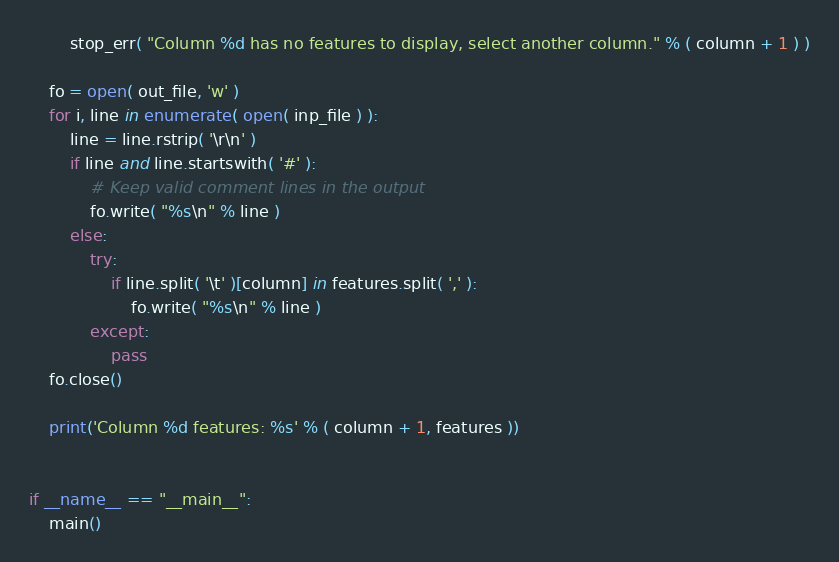<code> <loc_0><loc_0><loc_500><loc_500><_Python_>        stop_err( "Column %d has no features to display, select another column." % ( column + 1 ) )

    fo = open( out_file, 'w' )
    for i, line in enumerate( open( inp_file ) ):
        line = line.rstrip( '\r\n' )
        if line and line.startswith( '#' ):
            # Keep valid comment lines in the output
            fo.write( "%s\n" % line )
        else:
            try:
                if line.split( '\t' )[column] in features.split( ',' ):
                    fo.write( "%s\n" % line )
            except:
                pass
    fo.close()

    print('Column %d features: %s' % ( column + 1, features ))


if __name__ == "__main__":
    main()
</code> 